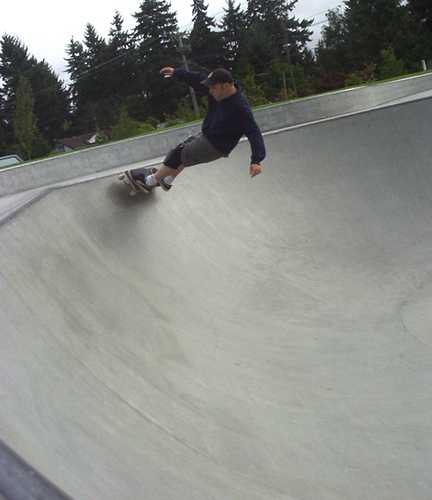Describe the objects in this image and their specific colors. I can see people in white, black, gray, and maroon tones and skateboard in white, gray, black, and darkgray tones in this image. 